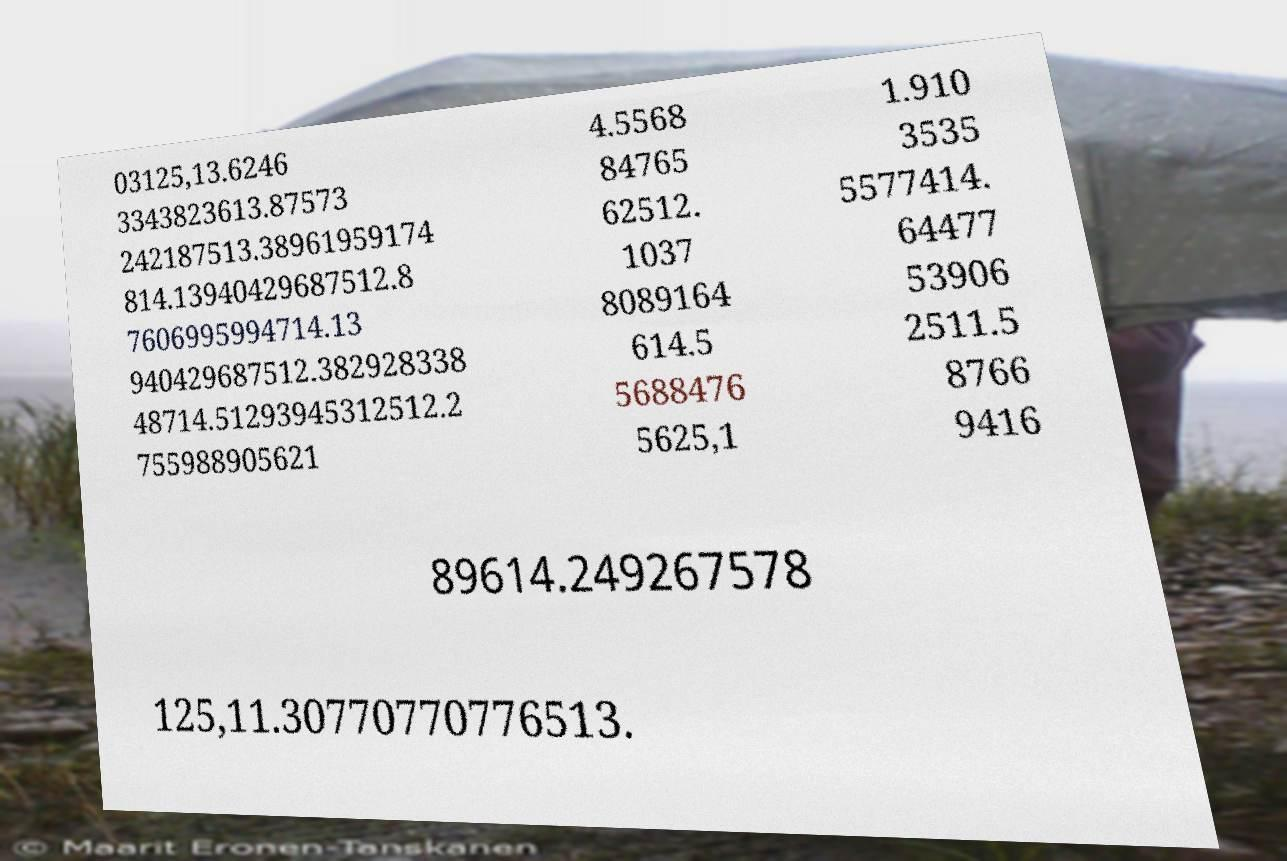Can you accurately transcribe the text from the provided image for me? 03125,13.6246 3343823613.87573 242187513.38961959174 814.13940429687512.8 7606995994714.13 940429687512.382928338 48714.51293945312512.2 755988905621 4.5568 84765 62512. 1037 8089164 614.5 5688476 5625,1 1.910 3535 5577414. 64477 53906 2511.5 8766 9416 89614.249267578 125,11.30770770776513. 